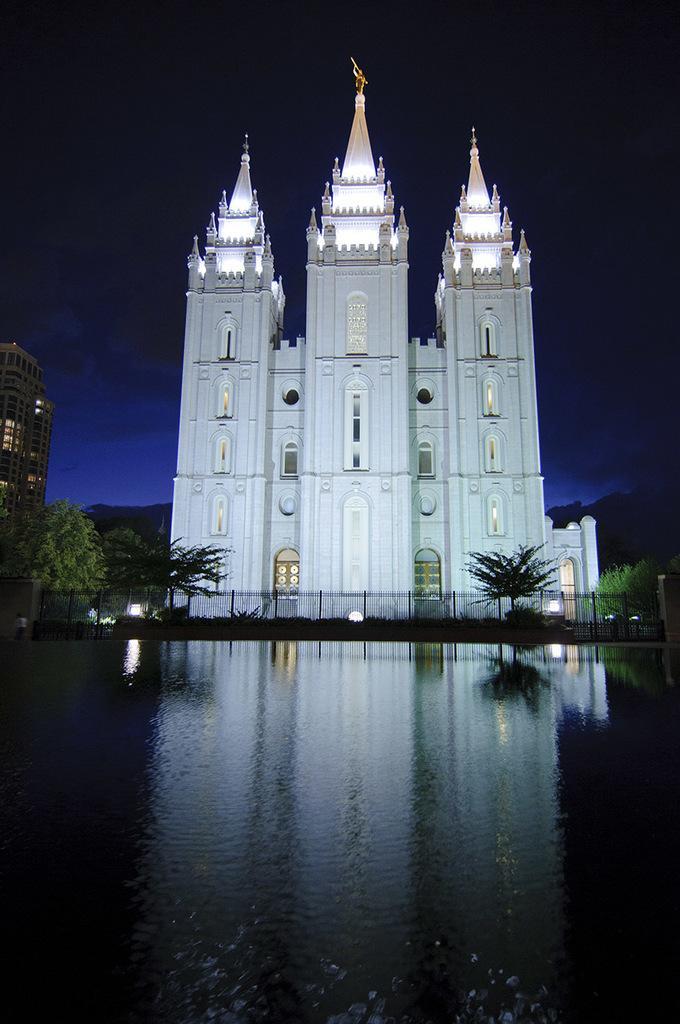How would you summarize this image in a sentence or two? In the center of the image we can see the water body. In the background, we can see buildings, trees, lights and a fence. 